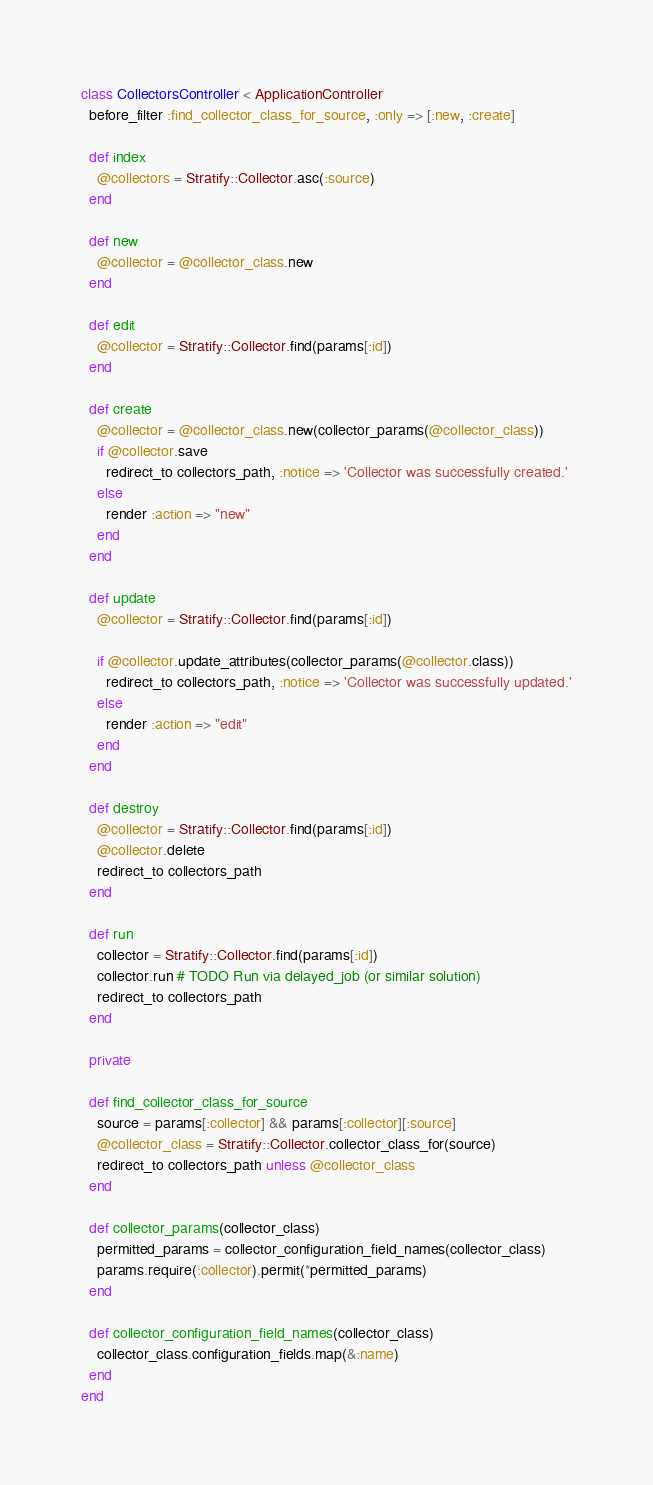<code> <loc_0><loc_0><loc_500><loc_500><_Ruby_>class CollectorsController < ApplicationController
  before_filter :find_collector_class_for_source, :only => [:new, :create]

  def index
    @collectors = Stratify::Collector.asc(:source)
  end

  def new
    @collector = @collector_class.new
  end

  def edit
    @collector = Stratify::Collector.find(params[:id])
  end

  def create
    @collector = @collector_class.new(collector_params(@collector_class))
    if @collector.save
      redirect_to collectors_path, :notice => 'Collector was successfully created.'
    else
      render :action => "new"
    end
  end

  def update
    @collector = Stratify::Collector.find(params[:id])

    if @collector.update_attributes(collector_params(@collector.class))
      redirect_to collectors_path, :notice => 'Collector was successfully updated.'
    else
      render :action => "edit"
    end
  end

  def destroy
    @collector = Stratify::Collector.find(params[:id])
    @collector.delete
    redirect_to collectors_path
  end

  def run
    collector = Stratify::Collector.find(params[:id])
    collector.run # TODO Run via delayed_job (or similar solution)
    redirect_to collectors_path
  end

  private

  def find_collector_class_for_source
    source = params[:collector] && params[:collector][:source]
    @collector_class = Stratify::Collector.collector_class_for(source)
    redirect_to collectors_path unless @collector_class
  end

  def collector_params(collector_class)
    permitted_params = collector_configuration_field_names(collector_class)
    params.require(:collector).permit(*permitted_params)
  end

  def collector_configuration_field_names(collector_class)
    collector_class.configuration_fields.map(&:name)
  end
end
</code> 